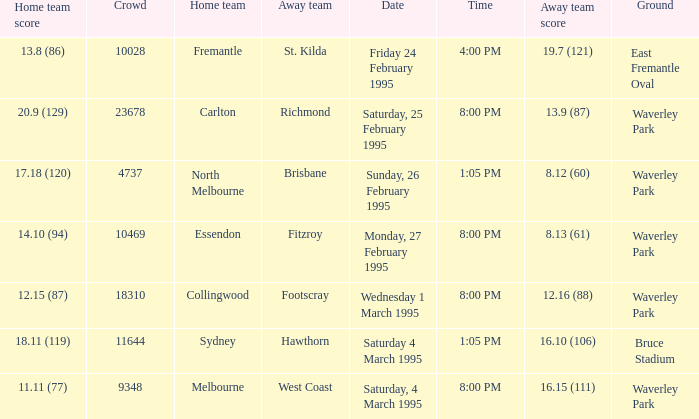Name the ground for essendon Waverley Park. 